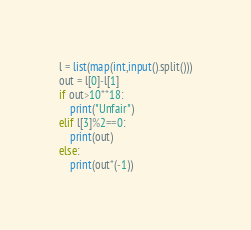Convert code to text. <code><loc_0><loc_0><loc_500><loc_500><_Python_>l = list(map(int,input().split()))
out = l[0]-l[1]
if out>10**18:
    print("Unfair")
elif l[3]%2==0:
    print(out)
else:
    print(out*(-1))</code> 